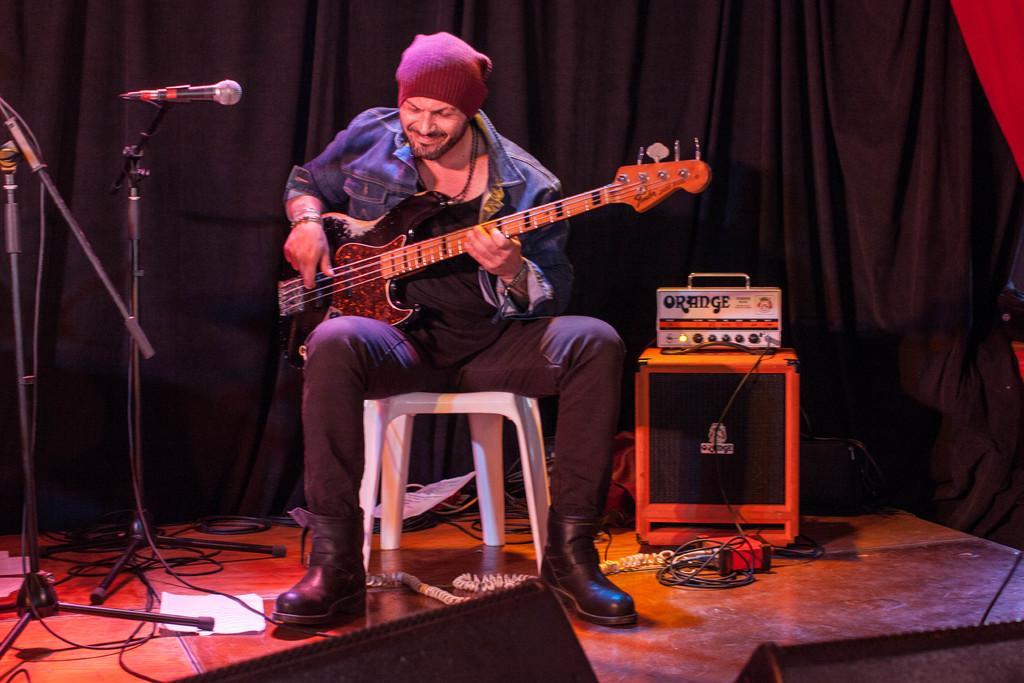Please provide a concise description of this image. In this image I can see the person holding the guitar. To the left there is a mic and to the right there is a sound box. In the background there is a cloth. 